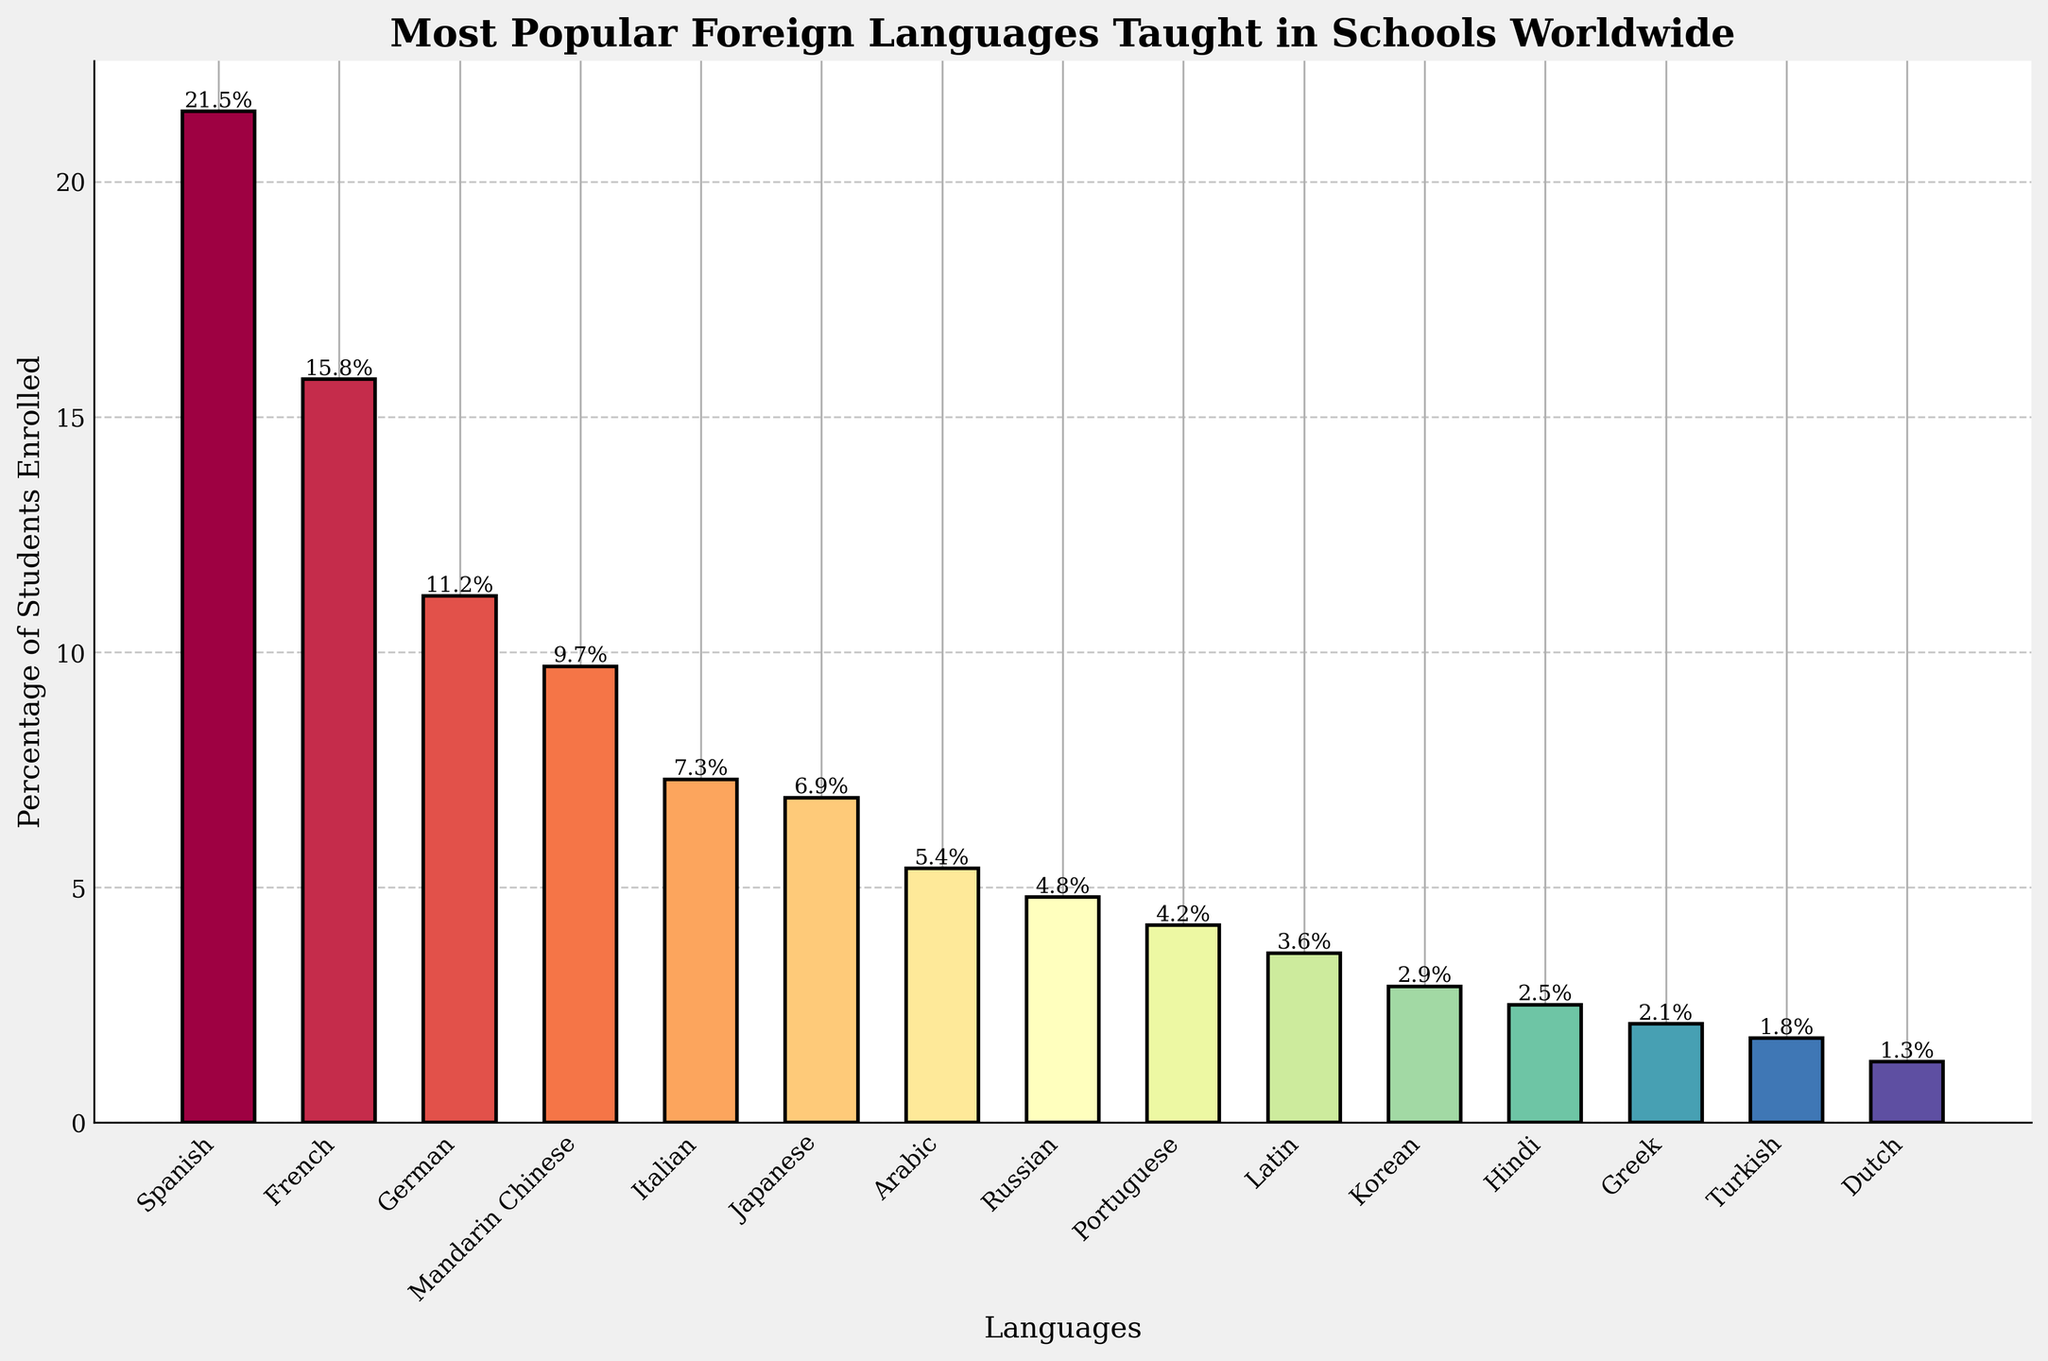What is the most popular foreign language taught in schools worldwide? The tallest bar in the chart represents Spanish with a percentage of 21.5%, making it the most popular foreign language taught in schools.
Answer: Spanish Which language has the lowest percentage of students enrolled? The shortest bar corresponds to Dutch with a percentage of 1.3%, indicating it has the lowest enrollment rate among the listed languages.
Answer: Dutch By how much does the percentage of students enrolled in Spanish exceed the percentage of students enrolled in Mandarin Chinese? Spanish has 21.5% and Mandarin Chinese has 9.7%. The difference is calculated as 21.5% - 9.7% = 11.8%.
Answer: 11.8% Which languages have a percentage of students enrolled greater than 10%? Spanish (21.5%), French (15.8%), and German (11.2%) are the languages with enrollment percentages greater than 10% as indicated by their tall bars exceeding the 10% mark.
Answer: Spanish, French, German How does the bar of Japanese visually compare to the bar of Italian in terms of height? The bar for Japanese is shorter than the bar for Italian but not by much, suggesting a slightly lower enrollment percentage for Japanese.
Answer: Japanese is slightly shorter What is the combined percentage of students enrolled in Latin and Greek? Latin has 3.6% and Greek has 2.1%. Their combined percentage is 3.6% + 2.1% = 5.7%.
Answer: 5.7% Which languages have an enrollment percentage of less than 5%? Arabiㅑ (5.4%), Russian (4.8%), Portuguese (4.2%), Latin (3.6%), Korean (2.9%), Hindi (2.5%), Greek (2.1%), Turkish (1.8%), and Dutch (1.3%) all have bars that fall below the 5% mark.
Answer: Russian, Portuguese, Latin, Korean, Hindi, Greek, Turkish, Dutch Is the percentage of students enrolled in Korean closer to that of Hindi or Greek? Korean has 2.9%, Hindi has 2.5%, and Greek has 2.1%. The difference between Korean and Hindi is 2.9% - 2.5% = 0.4%, while the difference between Korean and Greek is 2.9% - 2.1% = 0.8%, making Korean closer to Hindi.
Answer: Hindi If you sum the percentages of Spanish, French, and German, what value do you get? Adding the percentages of Spanish (21.5%), French (15.8%), and German (11.2%) results in a total of 21.5% + 15.8% + 11.2% = 48.5%.
Answer: 48.5% What is the difference in enrollment percentage between Italian and Arabic? Italian has an enrollment percentage of 7.3% while Arabic has 5.4%. The difference is calculated as 7.3% - 5.4% = 1.9%.
Answer: 1.9% 